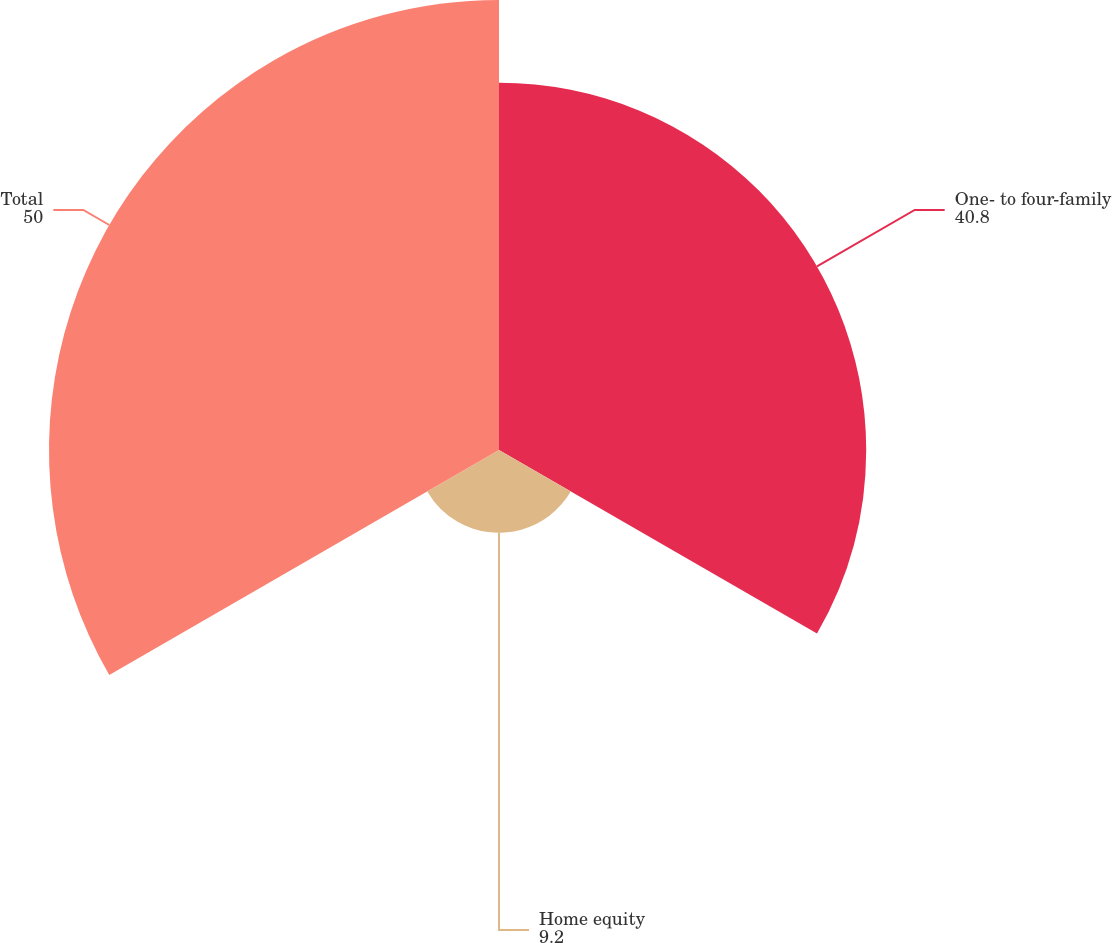Convert chart to OTSL. <chart><loc_0><loc_0><loc_500><loc_500><pie_chart><fcel>One- to four-family<fcel>Home equity<fcel>Total<nl><fcel>40.8%<fcel>9.2%<fcel>50.0%<nl></chart> 